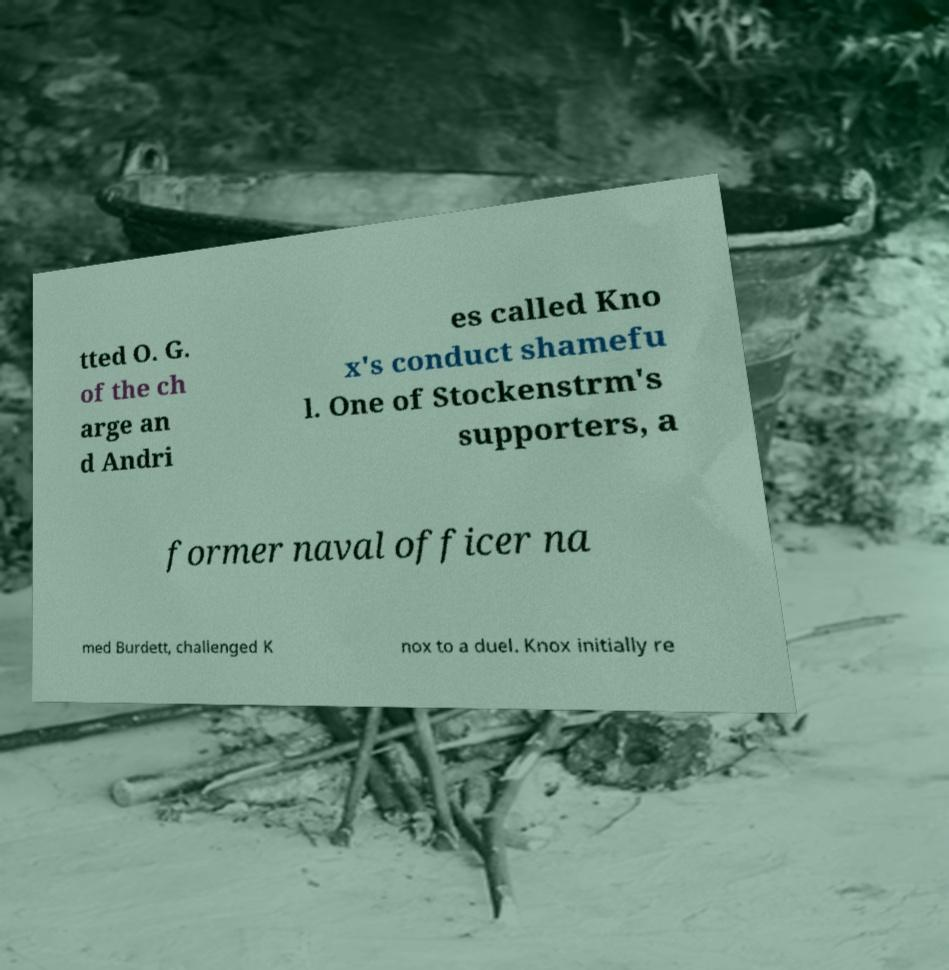Please read and relay the text visible in this image. What does it say? tted O. G. of the ch arge an d Andri es called Kno x's conduct shamefu l. One of Stockenstrm's supporters, a former naval officer na med Burdett, challenged K nox to a duel. Knox initially re 